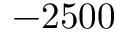<formula> <loc_0><loc_0><loc_500><loc_500>- 2 5 0 0</formula> 